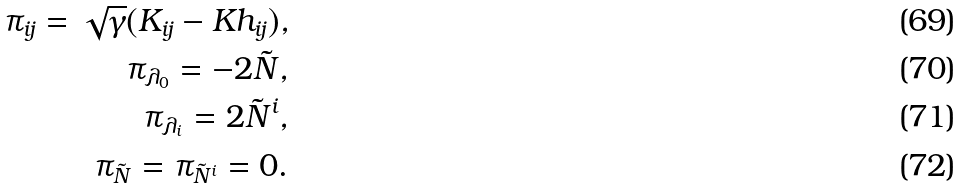<formula> <loc_0><loc_0><loc_500><loc_500>\pi _ { i j } = \sqrt { \gamma } ( K _ { i j } - K h _ { i j } ) , \\ \pi _ { \lambda _ { 0 } } = - 2 \tilde { N } , \\ \pi _ { \lambda _ { i } } = 2 \tilde { N } ^ { i } , \\ \pi _ { \tilde { N } } = \pi _ { \tilde { N } ^ { i } } = 0 .</formula> 